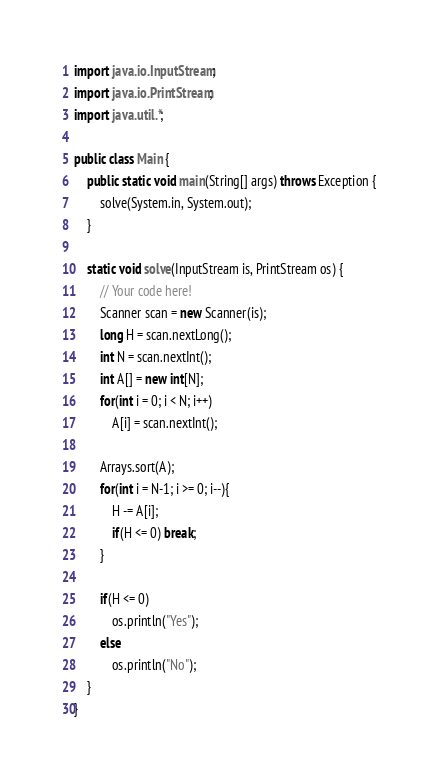<code> <loc_0><loc_0><loc_500><loc_500><_Java_>import java.io.InputStream;
import java.io.PrintStream;
import java.util.*;

public class Main {
    public static void main(String[] args) throws Exception {
        solve(System.in, System.out);
    }

    static void solve(InputStream is, PrintStream os) {
        // Your code here!
        Scanner scan = new Scanner(is);
        long H = scan.nextLong();
        int N = scan.nextInt();
        int A[] = new int[N];
        for(int i = 0; i < N; i++)
            A[i] = scan.nextInt();

        Arrays.sort(A);
        for(int i = N-1; i >= 0; i--){
            H -= A[i];
            if(H <= 0) break;
        }

        if(H <= 0)
            os.println("Yes");
        else
            os.println("No");
    }
}</code> 